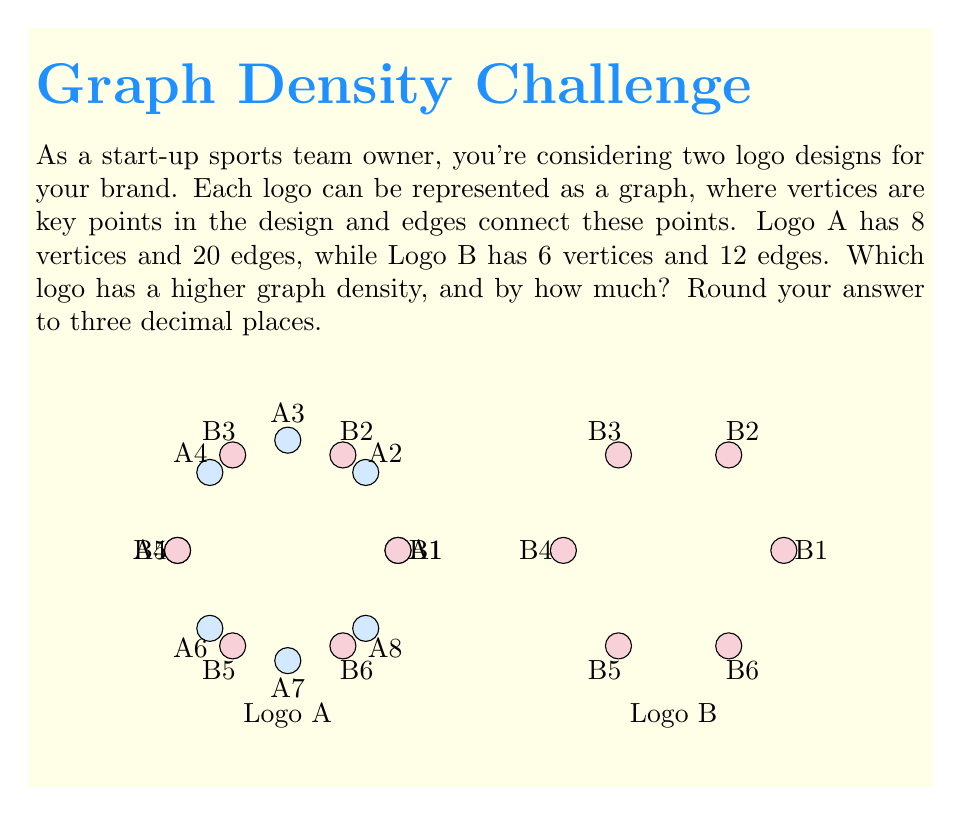Could you help me with this problem? To solve this problem, we need to calculate the graph density for both logos and compare them. The graph density for an undirected graph is given by the formula:

$$D = \frac{2|E|}{|V|(|V|-1)}$$

where $|E|$ is the number of edges and $|V|$ is the number of vertices.

1. For Logo A:
   $|V_A| = 8$, $|E_A| = 20$
   $$D_A = \frac{2(20)}{8(8-1)} = \frac{40}{56} \approx 0.714286$$

2. For Logo B:
   $|V_B| = 6$, $|E_B| = 12$
   $$D_B = \frac{2(12)}{6(6-1)} = \frac{24}{30} = 0.8$$

3. Comparing the densities:
   $D_B - D_A = 0.8 - 0.714286 = 0.085714$

4. Rounding to three decimal places:
   $0.085714 \approx 0.086$

Therefore, Logo B has a higher graph density, and the difference is 0.086 when rounded to three decimal places.
Answer: Logo B; 0.086 